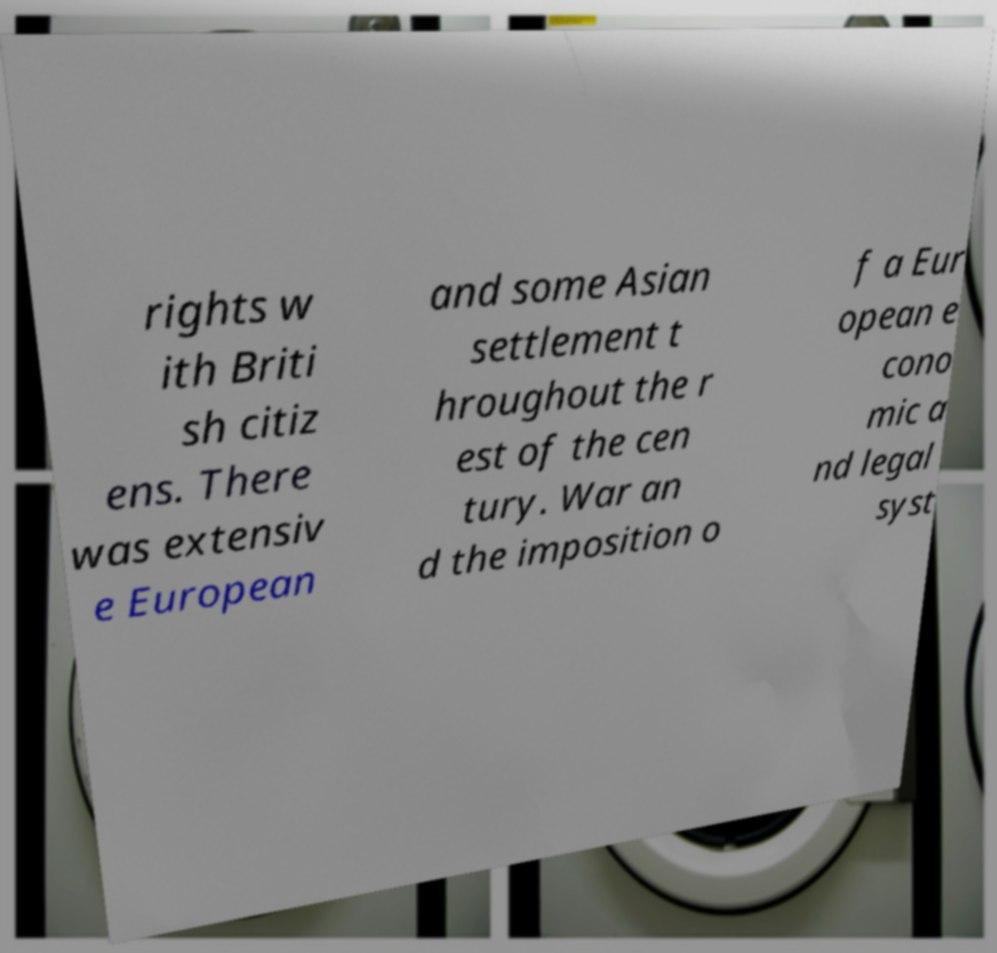I need the written content from this picture converted into text. Can you do that? rights w ith Briti sh citiz ens. There was extensiv e European and some Asian settlement t hroughout the r est of the cen tury. War an d the imposition o f a Eur opean e cono mic a nd legal syst 